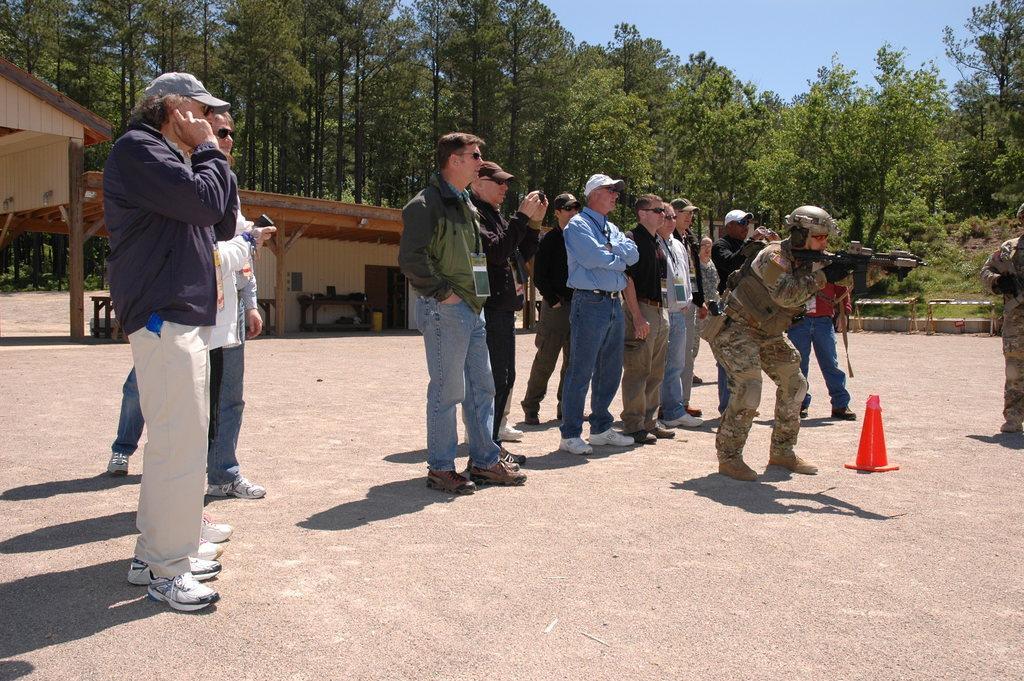How would you summarize this image in a sentence or two? In this image I can see the ground, a traffic pole and number of persons standing. I can see a person is holding a weapon in his hand. In the background I can see few sheds, few trees which are green in color and the sky. 